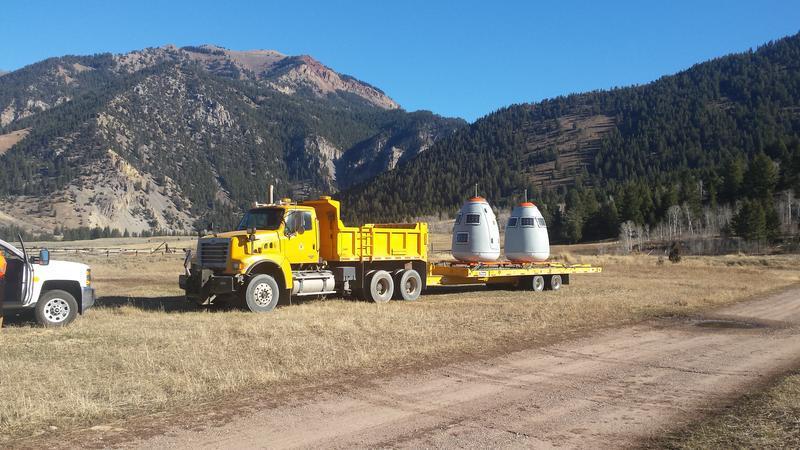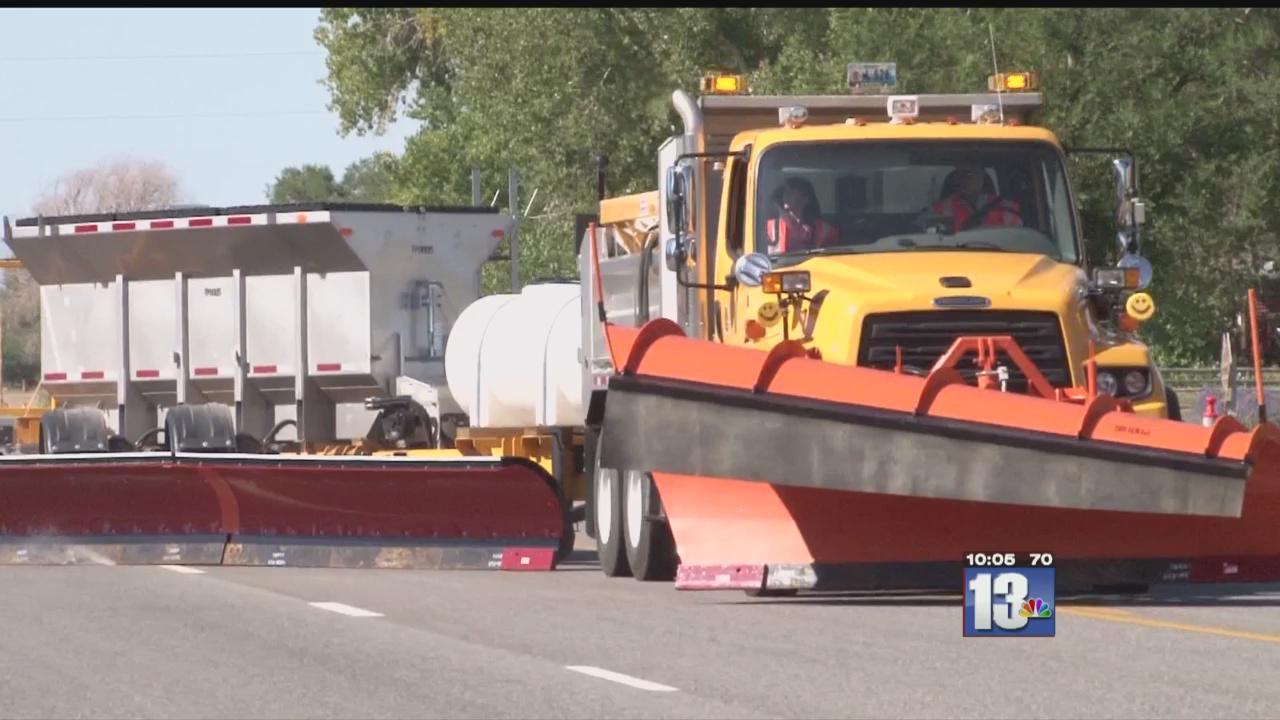The first image is the image on the left, the second image is the image on the right. Evaluate the accuracy of this statement regarding the images: "At the center of one image is a truck without a snow plow attached in front, and the truck has a yellow cab.". Is it true? Answer yes or no. Yes. The first image is the image on the left, the second image is the image on the right. Considering the images on both sides, is "A yellow truck is facing left." valid? Answer yes or no. Yes. 